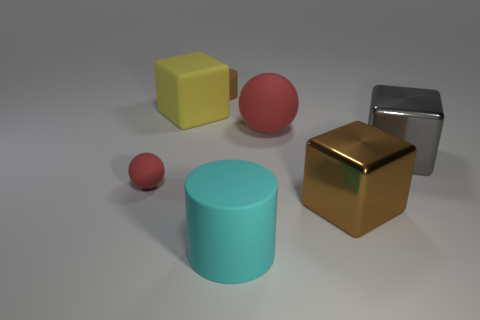Subtract all big metal cubes. How many cubes are left? 1 Add 1 tiny yellow metal objects. How many objects exist? 8 Subtract all gray blocks. How many blocks are left? 2 Subtract all green cylinders. How many yellow cubes are left? 1 Subtract 1 cylinders. How many cylinders are left? 1 Subtract all tiny objects. Subtract all rubber things. How many objects are left? 0 Add 5 large yellow cubes. How many large yellow cubes are left? 6 Add 7 large gray metal objects. How many large gray metal objects exist? 8 Subtract 0 red cubes. How many objects are left? 7 Subtract all cubes. How many objects are left? 4 